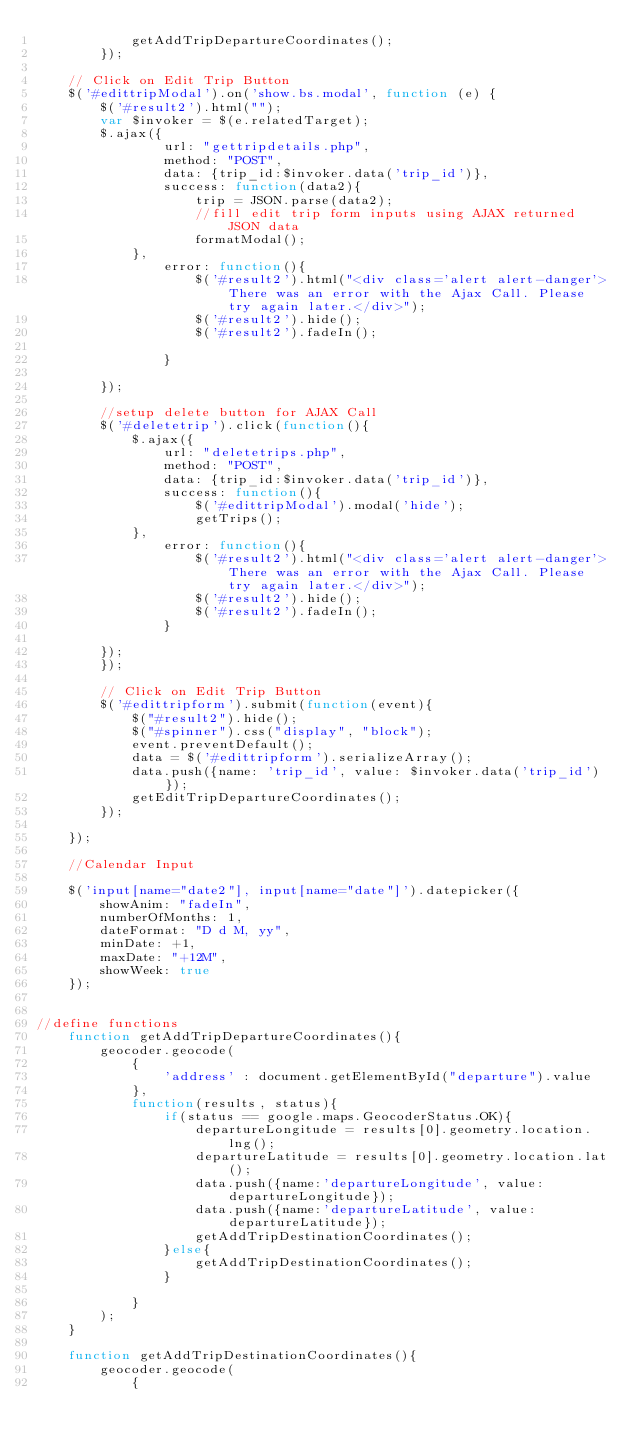<code> <loc_0><loc_0><loc_500><loc_500><_JavaScript_>            getAddTripDepartureCoordinates();
        });
    
    // Click on Edit Trip Button
    $('#edittripModal').on('show.bs.modal', function (e) {
        $('#result2').html("");
        var $invoker = $(e.relatedTarget);
        $.ajax({
                url: "gettripdetails.php",
                method: "POST",
                data: {trip_id:$invoker.data('trip_id')},
                success: function(data2){
                    trip = JSON.parse(data2);
                    //fill edit trip form inputs using AJAX returned JSON data
                    formatModal();
            },
                error: function(){
                    $('#result2').html("<div class='alert alert-danger'>There was an error with the Ajax Call. Please try again later.</div>");
                    $('#result2').hide();
                    $('#result2').fadeIn();
        
                }
            
        });
        
        //setup delete button for AJAX Call
        $('#deletetrip').click(function(){
            $.ajax({
                url: "deletetrips.php",
                method: "POST",
                data: {trip_id:$invoker.data('trip_id')},
                success: function(){
                    $('#edittripModal').modal('hide');
                    getTrips();
            },
                error: function(){
                    $('#result2').html("<div class='alert alert-danger'>There was an error with the Ajax Call. Please try again later.</div>");
                    $('#result2').hide();
                    $('#result2').fadeIn();
                }
            
        });
        });
        
        // Click on Edit Trip Button
        $('#edittripform').submit(function(event){
            $("#result2").hide();
            $("#spinner").css("display", "block");
            event.preventDefault();
            data = $('#edittripform').serializeArray();
            data.push({name: 'trip_id', value: $invoker.data('trip_id')});
            getEditTripDepartureCoordinates();
        });
        
    });
    
    //Calendar Input

    $('input[name="date2"], input[name="date"]').datepicker({
        showAnim: "fadeIn",
        numberOfMonths: 1,
        dateFormat: "D d M, yy",
        minDate: +1,
        maxDate: "+12M",
        showWeek: true
    });
    

//define functions
    function getAddTripDepartureCoordinates(){
        geocoder.geocode(
            {
                'address' : document.getElementById("departure").value
            },
            function(results, status){
                if(status == google.maps.GeocoderStatus.OK){
                    departureLongitude = results[0].geometry.location.lng();
                    departureLatitude = results[0].geometry.location.lat();
                    data.push({name:'departureLongitude', value: departureLongitude});
                    data.push({name:'departureLatitude', value: departureLatitude});
                    getAddTripDestinationCoordinates();
                }else{
                    getAddTripDestinationCoordinates();
                }

            }
        );
    }

    function getAddTripDestinationCoordinates(){
        geocoder.geocode(
            {</code> 